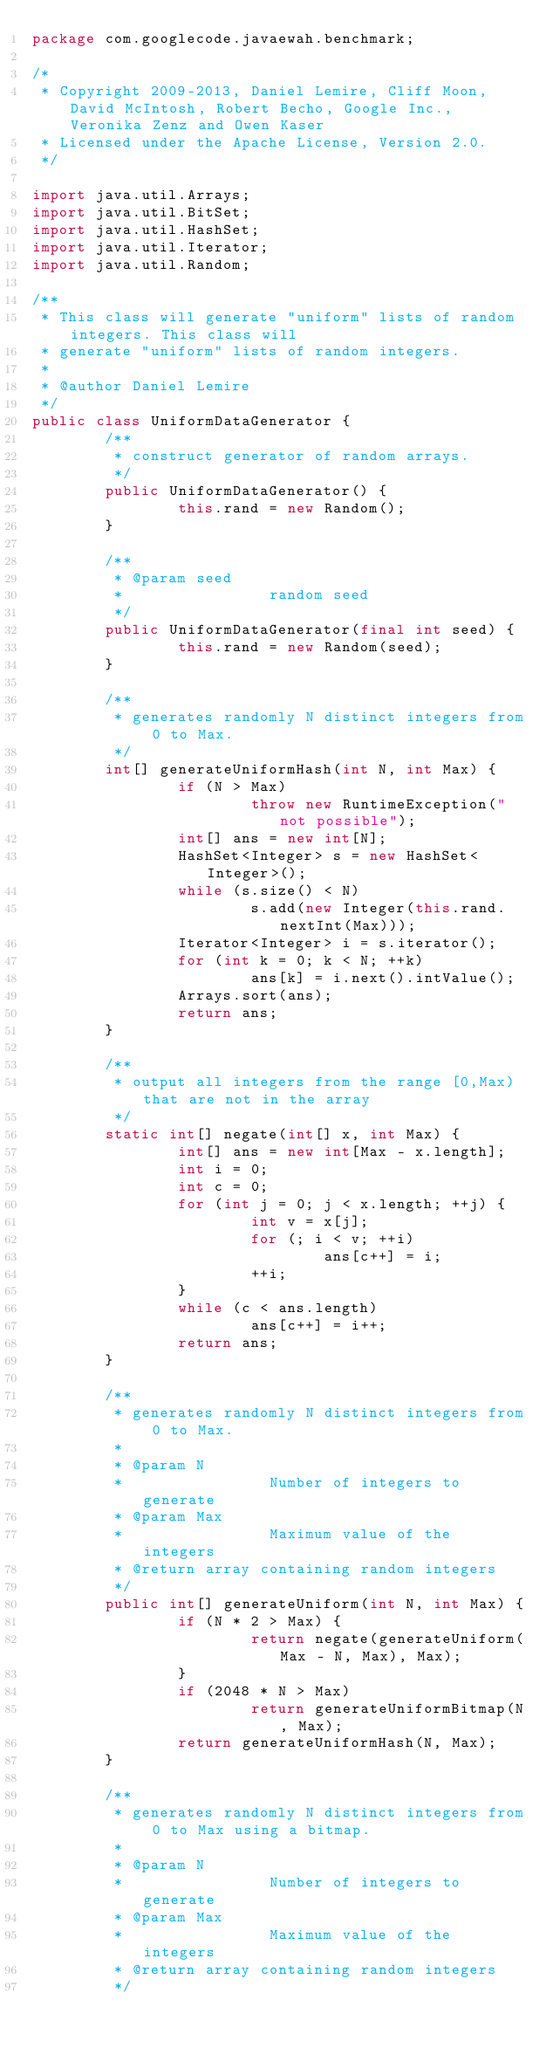Convert code to text. <code><loc_0><loc_0><loc_500><loc_500><_Java_>package com.googlecode.javaewah.benchmark;

/*
 * Copyright 2009-2013, Daniel Lemire, Cliff Moon, David McIntosh, Robert Becho, Google Inc., Veronika Zenz and Owen Kaser
 * Licensed under the Apache License, Version 2.0.
 */

import java.util.Arrays;
import java.util.BitSet;
import java.util.HashSet;
import java.util.Iterator;
import java.util.Random;

/**
 * This class will generate "uniform" lists of random integers. This class will
 * generate "uniform" lists of random integers.
 * 
 * @author Daniel Lemire
 */
public class UniformDataGenerator {
        /**
         * construct generator of random arrays.
         */
        public UniformDataGenerator() {
                this.rand = new Random();
        }

        /**
         * @param seed
         *                random seed
         */
        public UniformDataGenerator(final int seed) {
                this.rand = new Random(seed);
        }

        /**
         * generates randomly N distinct integers from 0 to Max.
         */
        int[] generateUniformHash(int N, int Max) {
                if (N > Max)
                        throw new RuntimeException("not possible");
                int[] ans = new int[N];
                HashSet<Integer> s = new HashSet<Integer>();
                while (s.size() < N)
                        s.add(new Integer(this.rand.nextInt(Max)));
                Iterator<Integer> i = s.iterator();
                for (int k = 0; k < N; ++k)
                        ans[k] = i.next().intValue();
                Arrays.sort(ans);
                return ans;
        }

        /**
         * output all integers from the range [0,Max) that are not in the array
         */
        static int[] negate(int[] x, int Max) {
                int[] ans = new int[Max - x.length];
                int i = 0;
                int c = 0;
                for (int j = 0; j < x.length; ++j) {
                        int v = x[j];
                        for (; i < v; ++i)
                                ans[c++] = i;
                        ++i;
                }
                while (c < ans.length)
                        ans[c++] = i++;
                return ans;
        }

        /**
         * generates randomly N distinct integers from 0 to Max.
         * 
         * @param N
         *                Number of integers to generate
         * @param Max
         *                Maximum value of the integers
         * @return array containing random integers
         */
        public int[] generateUniform(int N, int Max) {
                if (N * 2 > Max) {
                        return negate(generateUniform(Max - N, Max), Max);
                }
                if (2048 * N > Max)
                        return generateUniformBitmap(N, Max);
                return generateUniformHash(N, Max);
        }

        /**
         * generates randomly N distinct integers from 0 to Max using a bitmap.
         * 
         * @param N
         *                Number of integers to generate
         * @param Max
         *                Maximum value of the integers
         * @return array containing random integers
         */</code> 